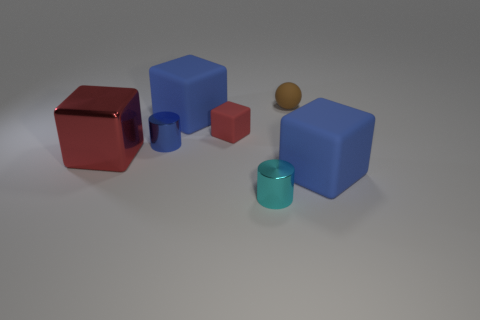Add 2 tiny red cubes. How many objects exist? 9 Subtract all large red cubes. How many cubes are left? 3 Subtract all purple blocks. Subtract all yellow balls. How many blocks are left? 4 Subtract all cylinders. How many objects are left? 5 Subtract all small matte cubes. Subtract all large red metal cubes. How many objects are left? 5 Add 7 large cubes. How many large cubes are left? 10 Add 5 small green cylinders. How many small green cylinders exist? 5 Subtract 1 cyan cylinders. How many objects are left? 6 